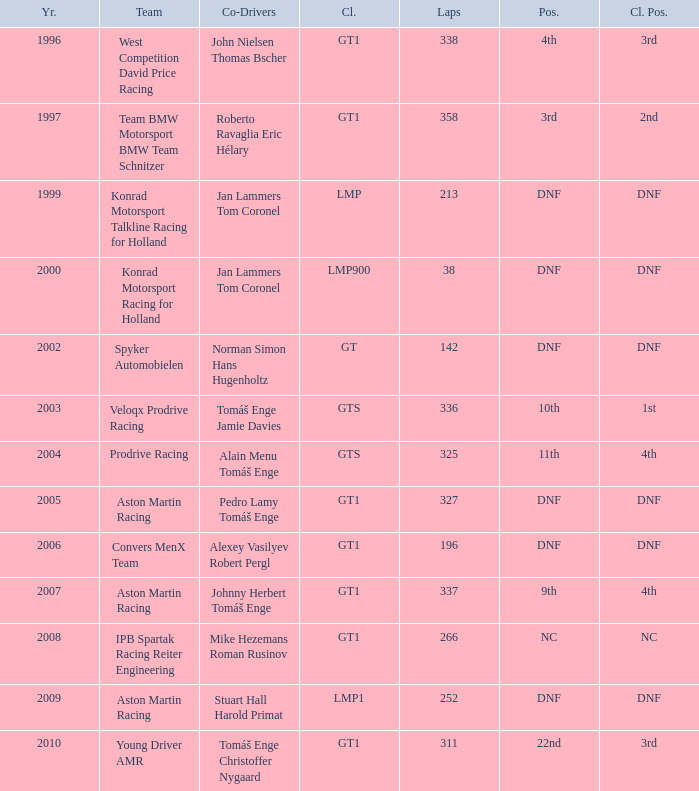In which class had 252 laps and a position of dnf? LMP1. 